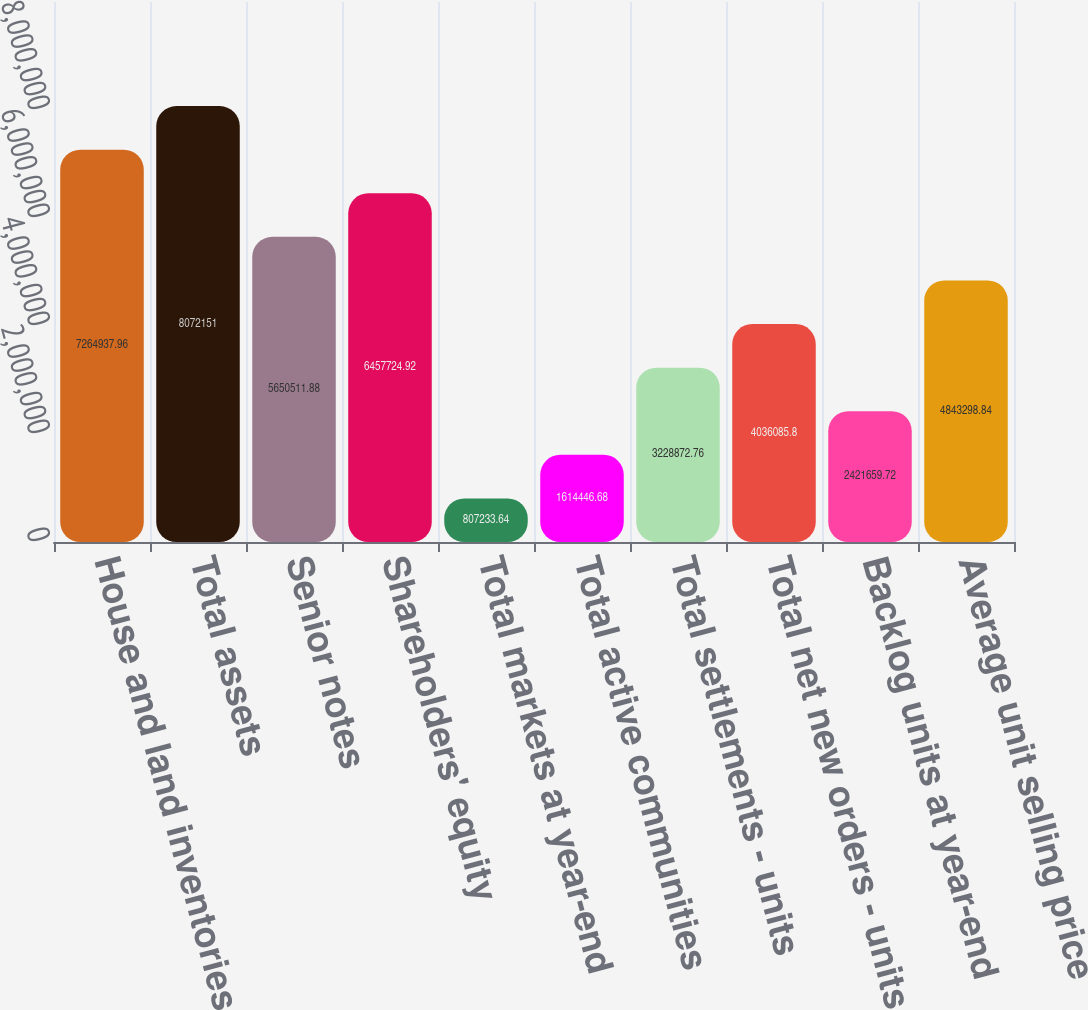Convert chart. <chart><loc_0><loc_0><loc_500><loc_500><bar_chart><fcel>House and land inventories<fcel>Total assets<fcel>Senior notes<fcel>Shareholders' equity<fcel>Total markets at year-end<fcel>Total active communities<fcel>Total settlements - units<fcel>Total net new orders - units<fcel>Backlog units at year-end<fcel>Average unit selling price<nl><fcel>7.26494e+06<fcel>8.07215e+06<fcel>5.65051e+06<fcel>6.45772e+06<fcel>807234<fcel>1.61445e+06<fcel>3.22887e+06<fcel>4.03609e+06<fcel>2.42166e+06<fcel>4.8433e+06<nl></chart> 